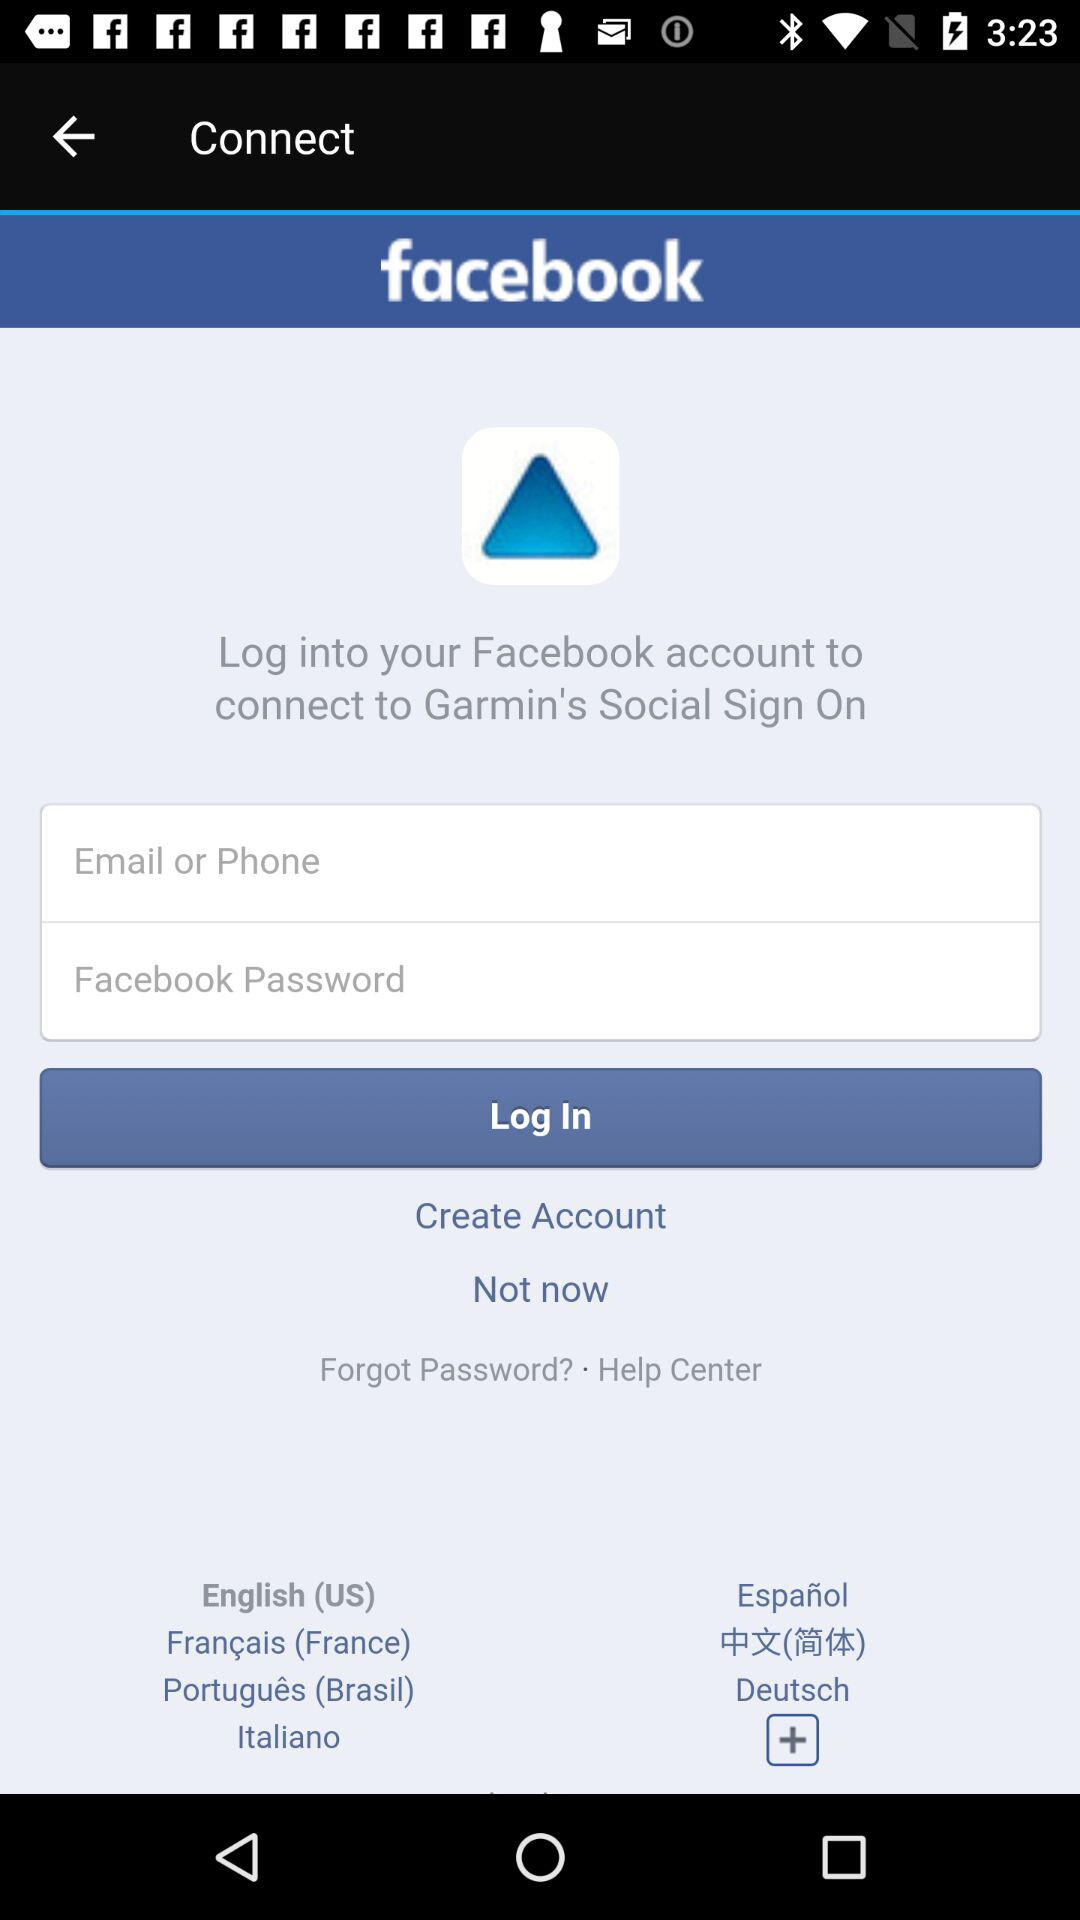What is the application name? The application name is "facebook". 